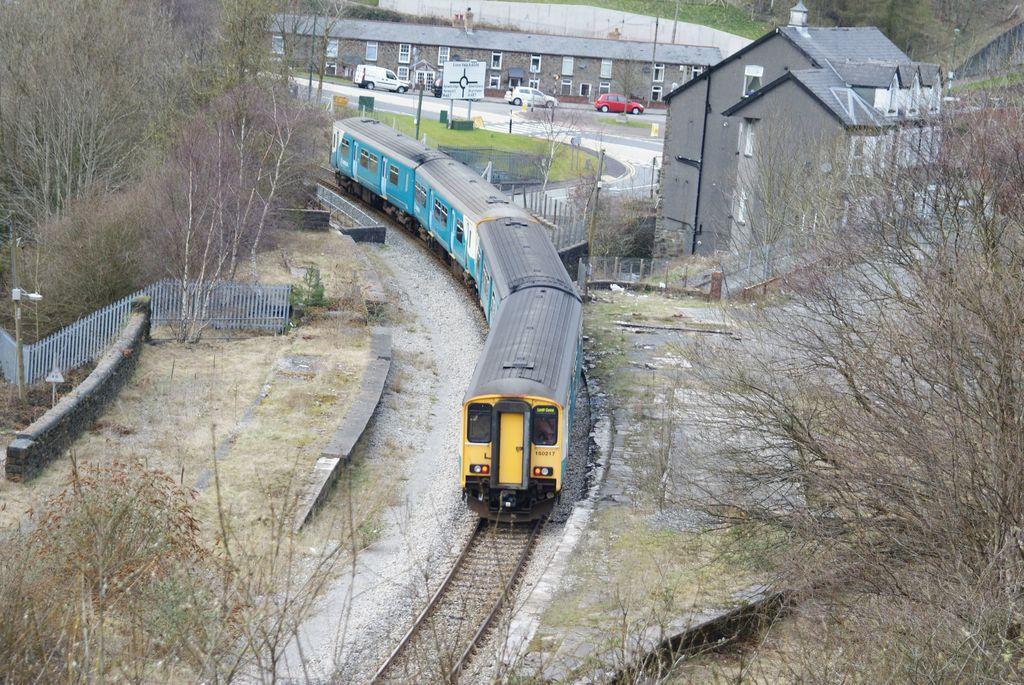Can you describe this image briefly? In the image I can see a train on the track and also I can see some trees, plants, fencing, cars and some buildings. 